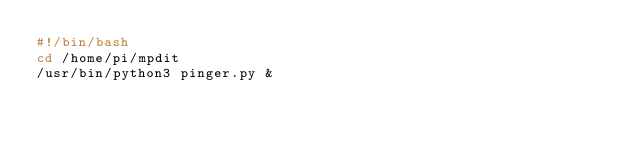<code> <loc_0><loc_0><loc_500><loc_500><_Bash_>#!/bin/bash
cd /home/pi/mpdit
/usr/bin/python3 pinger.py &

</code> 